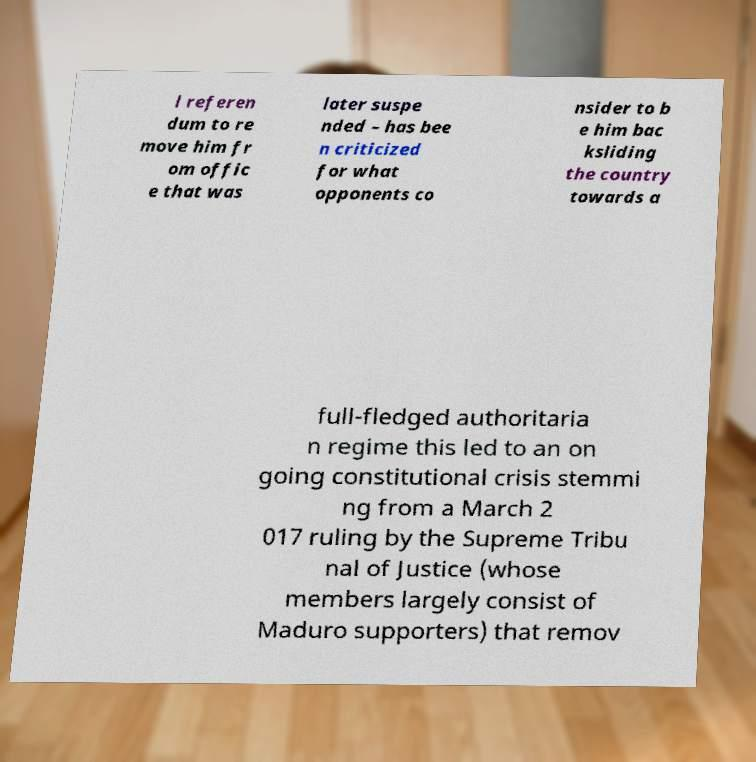Can you read and provide the text displayed in the image?This photo seems to have some interesting text. Can you extract and type it out for me? l referen dum to re move him fr om offic e that was later suspe nded – has bee n criticized for what opponents co nsider to b e him bac ksliding the country towards a full-fledged authoritaria n regime this led to an on going constitutional crisis stemmi ng from a March 2 017 ruling by the Supreme Tribu nal of Justice (whose members largely consist of Maduro supporters) that remov 